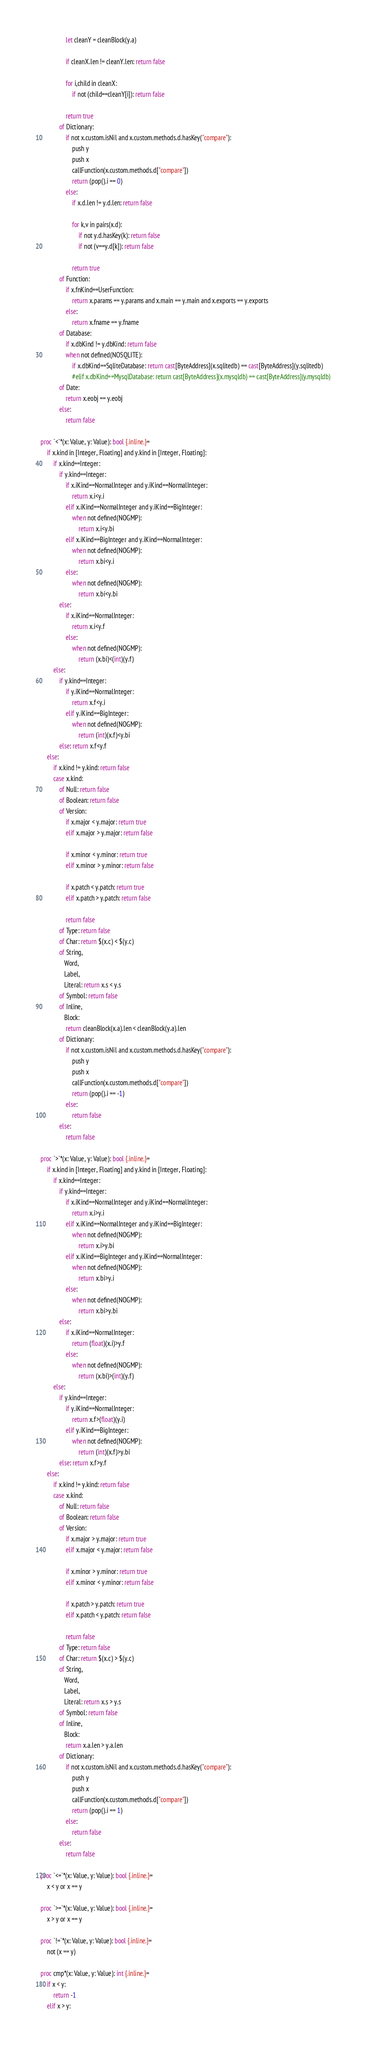<code> <loc_0><loc_0><loc_500><loc_500><_Nim_>                let cleanY = cleanBlock(y.a)

                if cleanX.len != cleanY.len: return false

                for i,child in cleanX:
                    if not (child==cleanY[i]): return false

                return true
            of Dictionary:
                if not x.custom.isNil and x.custom.methods.d.hasKey("compare"):
                    push y
                    push x
                    callFunction(x.custom.methods.d["compare"])
                    return (pop().i == 0)
                else:
                    if x.d.len != y.d.len: return false

                    for k,v in pairs(x.d):
                        if not y.d.hasKey(k): return false
                        if not (v==y.d[k]): return false

                    return true
            of Function:
                if x.fnKind==UserFunction:
                    return x.params == y.params and x.main == y.main and x.exports == y.exports
                else:
                    return x.fname == y.fname
            of Database:
                if x.dbKind != y.dbKind: return false
                when not defined(NOSQLITE):
                    if x.dbKind==SqliteDatabase: return cast[ByteAddress](x.sqlitedb) == cast[ByteAddress](y.sqlitedb)
                    #elif x.dbKind==MysqlDatabase: return cast[ByteAddress](x.mysqldb) == cast[ByteAddress](y.mysqldb)
            of Date:
                return x.eobj == y.eobj
            else:
                return false

proc `<`*(x: Value, y: Value): bool {.inline.}=
    if x.kind in [Integer, Floating] and y.kind in [Integer, Floating]:
        if x.kind==Integer:
            if y.kind==Integer: 
                if x.iKind==NormalInteger and y.iKind==NormalInteger:
                    return x.i<y.i
                elif x.iKind==NormalInteger and y.iKind==BigInteger:
                    when not defined(NOGMP):
                        return x.i<y.bi
                elif x.iKind==BigInteger and y.iKind==NormalInteger:
                    when not defined(NOGMP):
                        return x.bi<y.i
                else:
                    when not defined(NOGMP):
                        return x.bi<y.bi
            else: 
                if x.iKind==NormalInteger:
                    return x.i<y.f
                else:
                    when not defined(NOGMP):
                        return (x.bi)<(int)(y.f)
        else:
            if y.kind==Integer: 
                if y.iKind==NormalInteger:
                    return x.f<y.i
                elif y.iKind==BigInteger:
                    when not defined(NOGMP):
                        return (int)(x.f)<y.bi        
            else: return x.f<y.f
    else:
        if x.kind != y.kind: return false
        case x.kind:
            of Null: return false
            of Boolean: return false
            of Version:
                if x.major < y.major: return true
                elif x.major > y.major: return false

                if x.minor < y.minor: return true
                elif x.minor > y.minor: return false

                if x.patch < y.patch: return true
                elif x.patch > y.patch: return false

                return false
            of Type: return false
            of Char: return $(x.c) < $(y.c)
            of String,
               Word,
               Label,
               Literal: return x.s < y.s
            of Symbol: return false
            of Inline,
               Block:
                return cleanBlock(x.a).len < cleanBlock(y.a).len
            of Dictionary:
                if not x.custom.isNil and x.custom.methods.d.hasKey("compare"):
                    push y
                    push x
                    callFunction(x.custom.methods.d["compare"])
                    return (pop().i == -1)
                else:
                    return false
            else:
                return false

proc `>`*(x: Value, y: Value): bool {.inline.}=
    if x.kind in [Integer, Floating] and y.kind in [Integer, Floating]:
        if x.kind==Integer:
            if y.kind==Integer: 
                if x.iKind==NormalInteger and y.iKind==NormalInteger:
                    return x.i>y.i
                elif x.iKind==NormalInteger and y.iKind==BigInteger:
                    when not defined(NOGMP):
                        return x.i>y.bi
                elif x.iKind==BigInteger and y.iKind==NormalInteger:
                    when not defined(NOGMP):
                        return x.bi>y.i
                else:
                    when not defined(NOGMP):
                        return x.bi>y.bi
            else: 
                if x.iKind==NormalInteger:
                    return (float)(x.i)>y.f
                else:
                    when not defined(NOGMP):
                        return (x.bi)>(int)(y.f)
        else:
            if y.kind==Integer: 
                if y.iKind==NormalInteger:
                    return x.f>(float)(y.i)
                elif y.iKind==BigInteger:
                    when not defined(NOGMP):
                        return (int)(x.f)>y.bi        
            else: return x.f>y.f
    else:
        if x.kind != y.kind: return false
        case x.kind:
            of Null: return false
            of Boolean: return false
            of Version:
                if x.major > y.major: return true
                elif x.major < y.major: return false

                if x.minor > y.minor: return true
                elif x.minor < y.minor: return false

                if x.patch > y.patch: return true
                elif x.patch < y.patch: return false

                return false
            of Type: return false
            of Char: return $(x.c) > $(y.c)
            of String,
               Word,
               Label,
               Literal: return x.s > y.s
            of Symbol: return false
            of Inline,
               Block:
                return x.a.len > y.a.len
            of Dictionary:
                if not x.custom.isNil and x.custom.methods.d.hasKey("compare"):
                    push y
                    push x
                    callFunction(x.custom.methods.d["compare"])
                    return (pop().i == 1)
                else:
                    return false
            else:
                return false

proc `<=`*(x: Value, y: Value): bool {.inline.}=
    x < y or x == y

proc `>=`*(x: Value, y: Value): bool {.inline.}=
    x > y or x == y

proc `!=`*(x: Value, y: Value): bool {.inline.}=
    not (x == y)

proc cmp*(x: Value, y: Value): int {.inline.}=
    if x < y:
        return -1
    elif x > y:</code> 